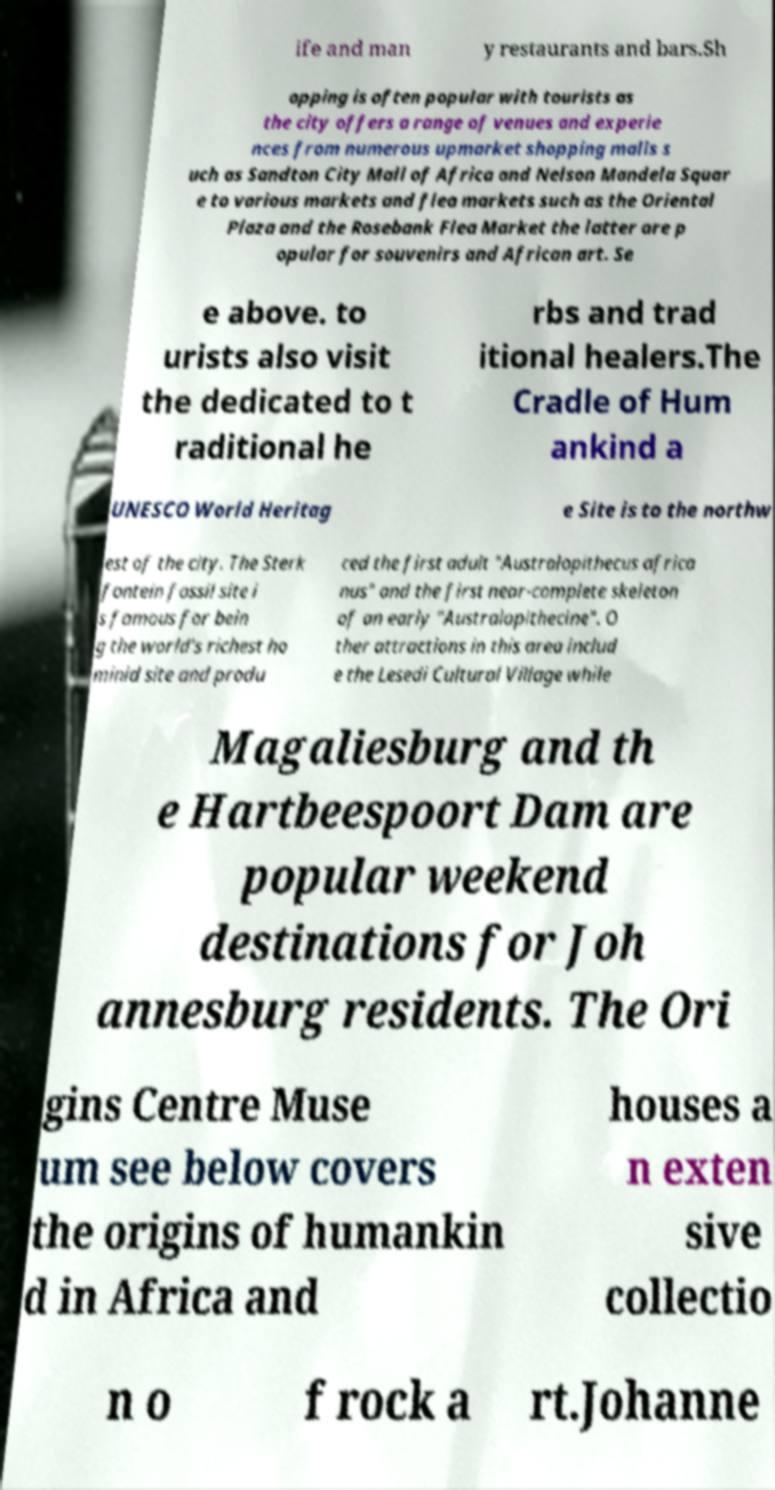Could you assist in decoding the text presented in this image and type it out clearly? ife and man y restaurants and bars.Sh opping is often popular with tourists as the city offers a range of venues and experie nces from numerous upmarket shopping malls s uch as Sandton City Mall of Africa and Nelson Mandela Squar e to various markets and flea markets such as the Oriental Plaza and the Rosebank Flea Market the latter are p opular for souvenirs and African art. Se e above. to urists also visit the dedicated to t raditional he rbs and trad itional healers.The Cradle of Hum ankind a UNESCO World Heritag e Site is to the northw est of the city. The Sterk fontein fossil site i s famous for bein g the world's richest ho minid site and produ ced the first adult "Australopithecus africa nus" and the first near-complete skeleton of an early "Australopithecine". O ther attractions in this area includ e the Lesedi Cultural Village while Magaliesburg and th e Hartbeespoort Dam are popular weekend destinations for Joh annesburg residents. The Ori gins Centre Muse um see below covers the origins of humankin d in Africa and houses a n exten sive collectio n o f rock a rt.Johanne 